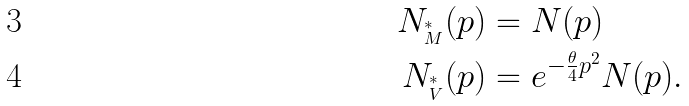<formula> <loc_0><loc_0><loc_500><loc_500>N _ { ^ { * } _ { M } } ( p ) & = N ( p ) \\ N _ { ^ { * } _ { V } } ( p ) & = e ^ { - \frac { \theta } { 4 } p ^ { 2 } } N ( p ) .</formula> 